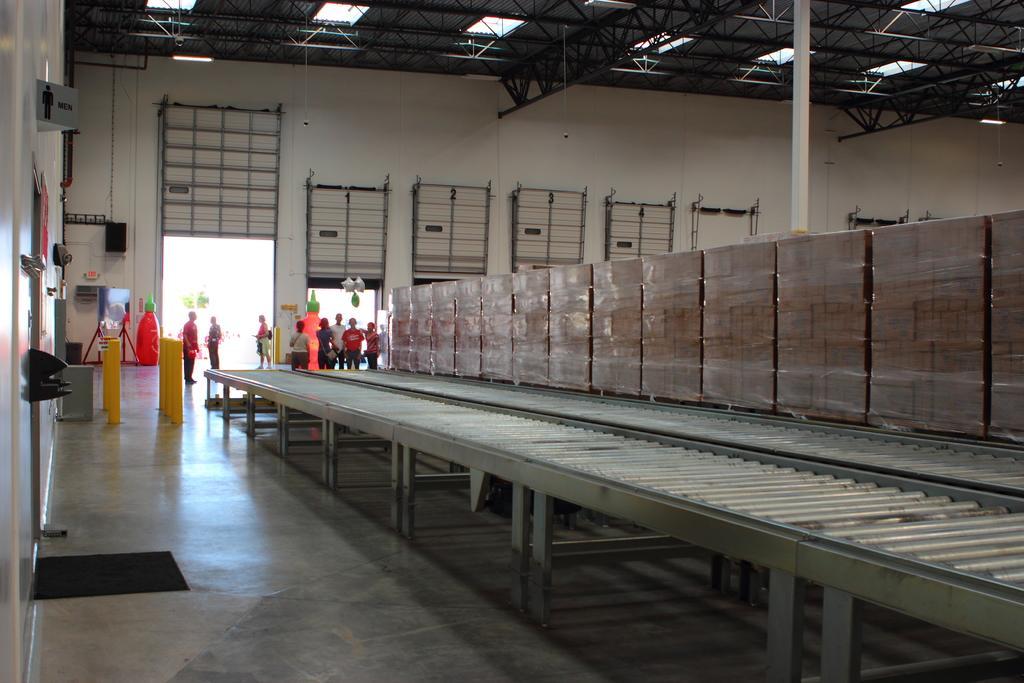Can you describe this image briefly? This is an inside view of a factory and here we can see boxes placed on the tables and in the background, there are boards, poles, shutters on the wall. At the top, there are lights and there is a roof. At the bottom, there is floor. 